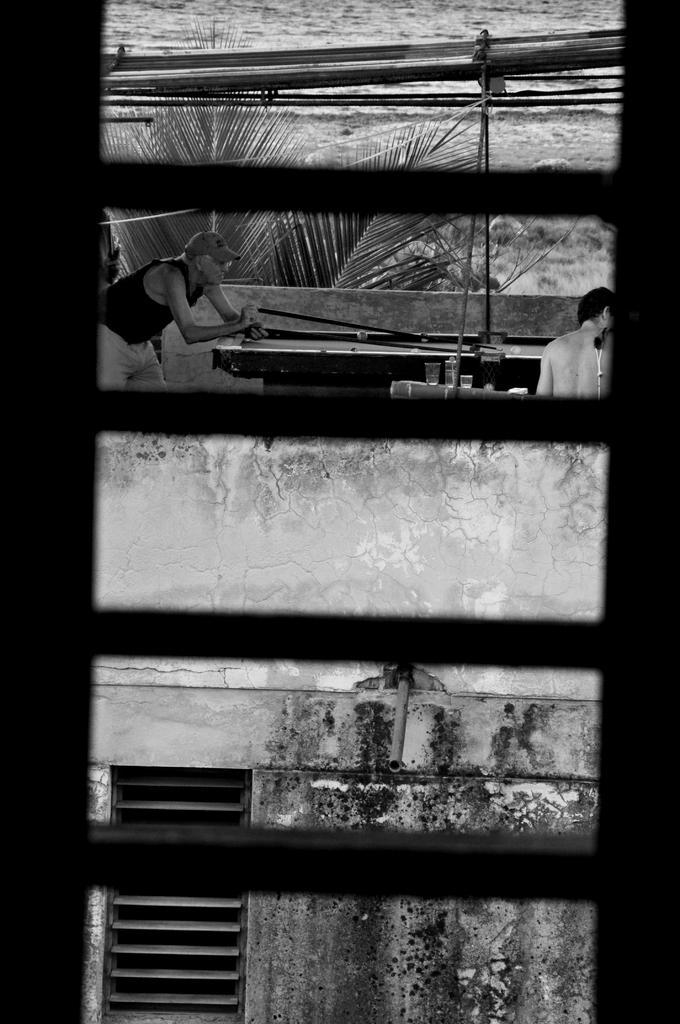Describe this image in one or two sentences. In the picture I can see a man and a person. I can also see a building, the water and some other objects. This picture is black and white in color. 